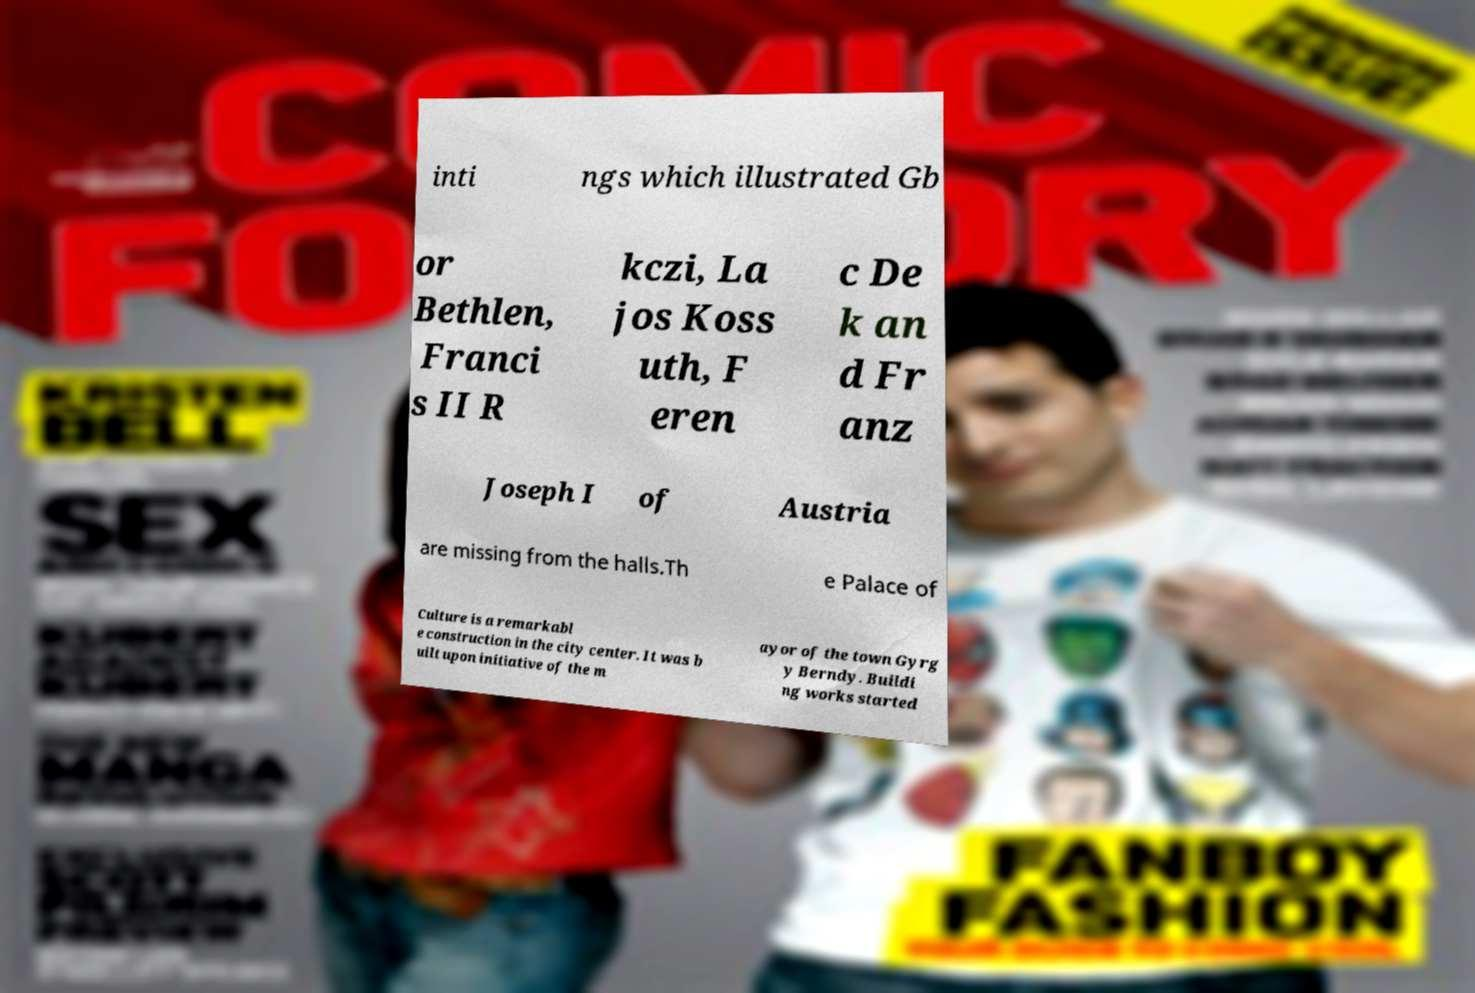Could you extract and type out the text from this image? inti ngs which illustrated Gb or Bethlen, Franci s II R kczi, La jos Koss uth, F eren c De k an d Fr anz Joseph I of Austria are missing from the halls.Th e Palace of Culture is a remarkabl e construction in the city center. It was b uilt upon initiative of the m ayor of the town Gyrg y Berndy. Buildi ng works started 